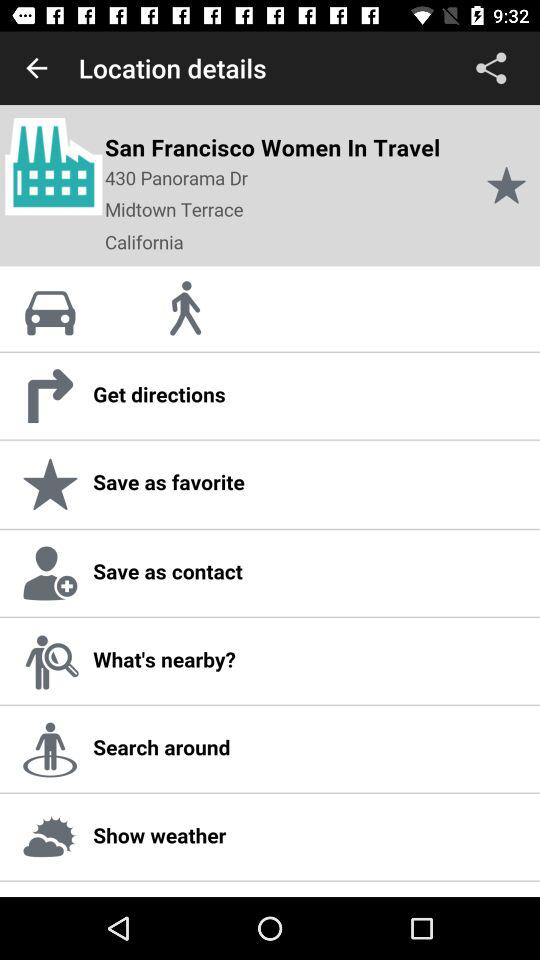What is the address of the user? The address is 430 Panorama Dr Midtown Terrace, California. 